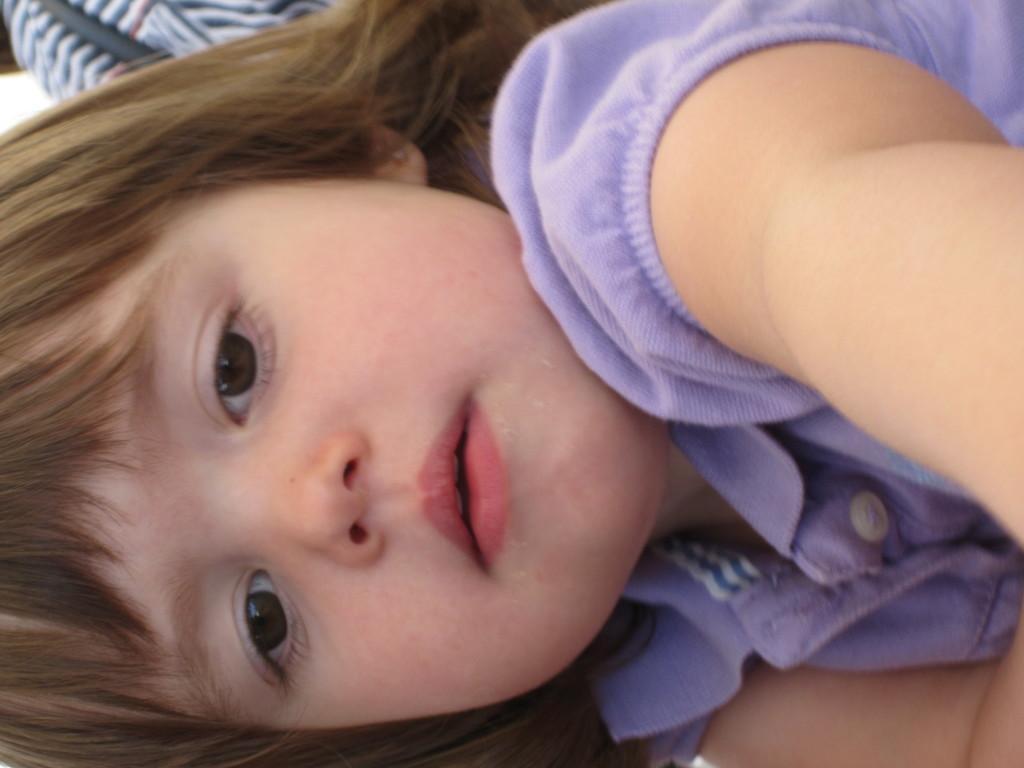Please provide a concise description of this image. In this image there is a girl, and in the background there is an object. 